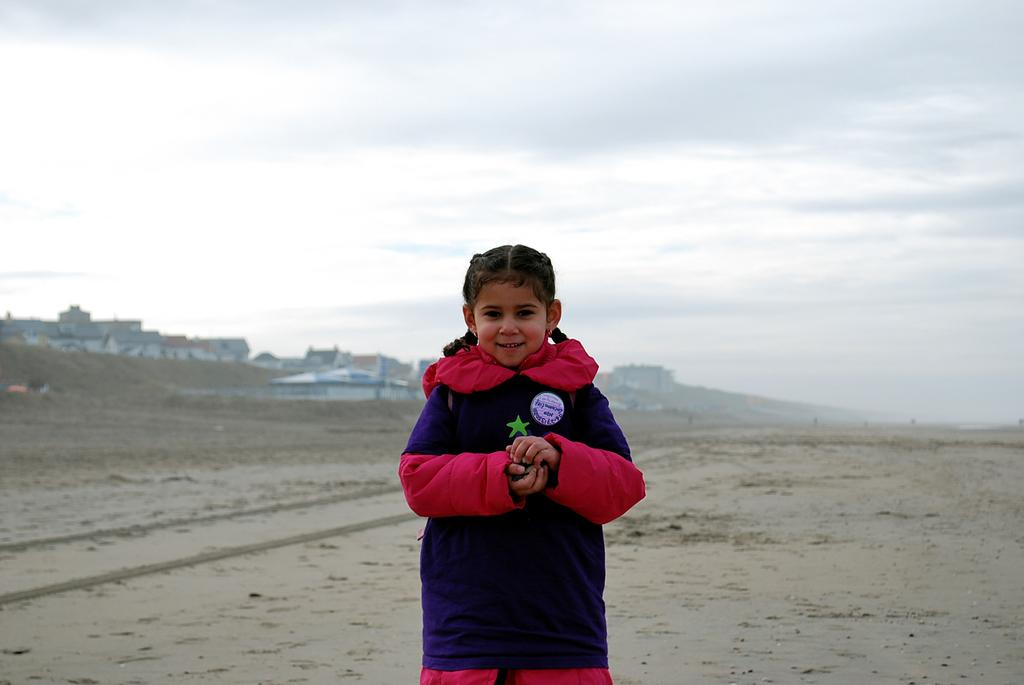What is the main subject of the picture? The main subject of the picture is a kid. What is the kid doing in the picture? The kid is standing and smiling. What can be seen at the bottom of the picture? There is soil at the bottom of the picture. What is visible in the background of the picture? There are buildings in the background of the picture. What is visible at the top of the picture? The sky is visible at the top of the picture. What type of bottle can be seen in the kid's hand in the image? There is no bottle visible in the kid's hand in the image. What color is the copper wire wrapped around the calculator in the image? There is no copper wire or calculator present in the image. 